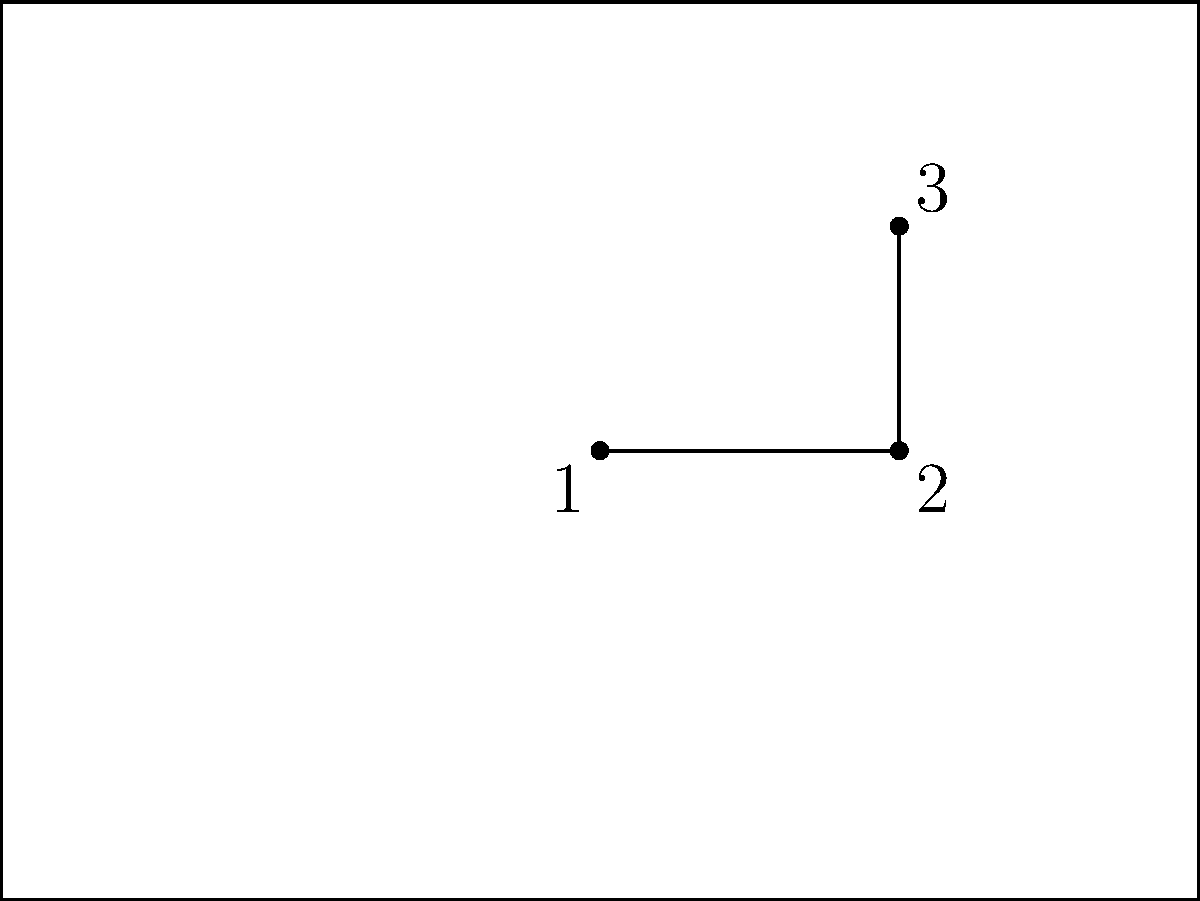In the diagram above, representing a football goal post and a corner flag, which angles are congruent to each other? Let's analyze this step-by-step:

1. The diagram shows a rectangular shape (ABCD) representing a goal post, and a right-angled triangle (EFG) representing a corner flag.

2. In a rectangle, all four angles are right angles (90°). This means that angles at points A, B, C, and D are all congruent to each other.

3. In the right-angled triangle EFG:
   - Angle 3 is clearly a right angle (90°), as it forms a perpendicular with the ground.
   - Angles 1 and 2 are complementary, meaning they add up to 90°.

4. Comparing the goal post and the corner flag:
   - The right angle at point G (angle 3) is congruent to all the angles in the rectangular goal post (A, B, C, D).

5. Therefore, angle 3 and all four angles of the rectangular goal post are congruent to each other.

In football terms, this congruence ensures that the corner flag is perpendicular to the ground, just like the goal posts, maintaining consistency in the field setup.
Answer: Angle 3 and all four angles of the goal post (A, B, C, D) 